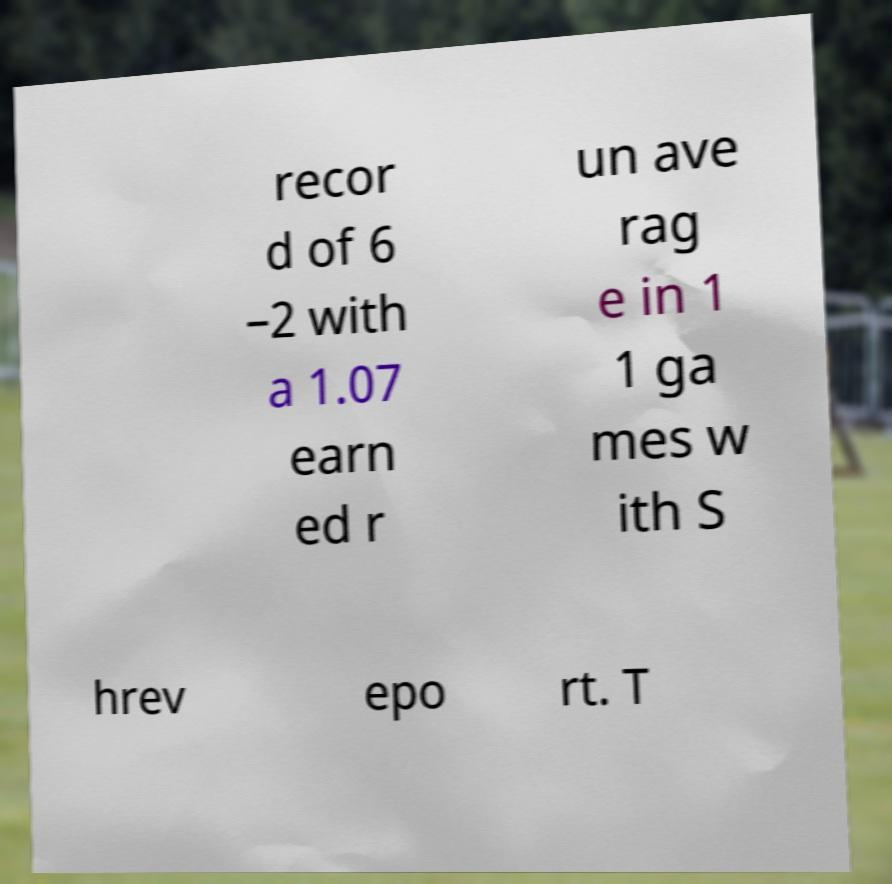What messages or text are displayed in this image? I need them in a readable, typed format. recor d of 6 –2 with a 1.07 earn ed r un ave rag e in 1 1 ga mes w ith S hrev epo rt. T 